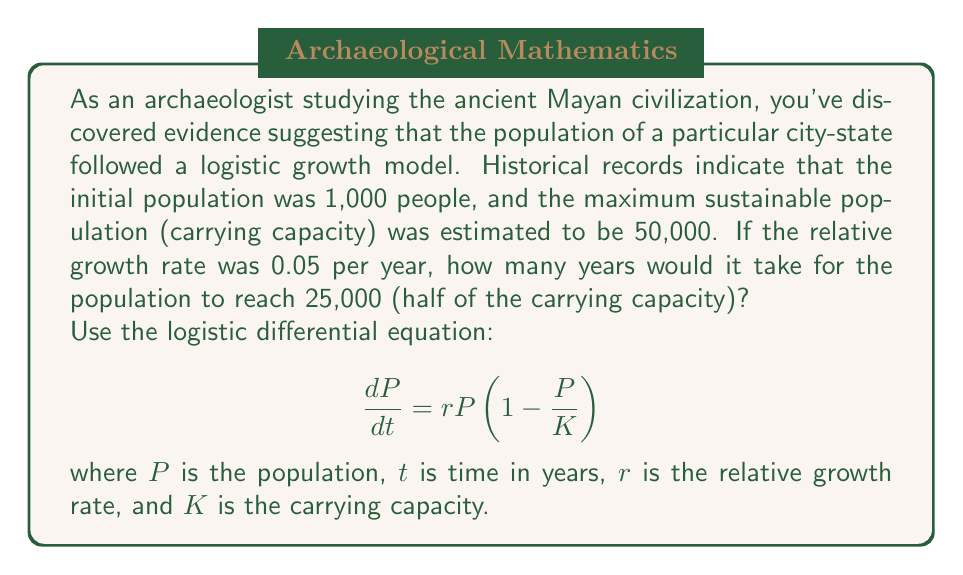Provide a solution to this math problem. To solve this problem, we'll use the analytical solution of the logistic differential equation:

$$P(t) = \frac{K}{1 + (\frac{K}{P_0} - 1)e^{-rt}}$$

Where:
$K = 50,000$ (carrying capacity)
$P_0 = 1,000$ (initial population)
$r = 0.05$ (relative growth rate)
$P(t) = 25,000$ (target population, half of carrying capacity)

Let's substitute these values into the equation:

$$25,000 = \frac{50,000}{1 + (\frac{50,000}{1,000} - 1)e^{-0.05t}}$$

Now, let's solve for $t$:

1) Simplify the fraction:
   $$\frac{1}{2} = \frac{1}{1 + 49e^{-0.05t}}$$

2) Take the reciprocal of both sides:
   $$2 = 1 + 49e^{-0.05t}$$

3) Subtract 1 from both sides:
   $$1 = 49e^{-0.05t}$$

4) Divide both sides by 49:
   $$\frac{1}{49} = e^{-0.05t}$$

5) Take the natural logarithm of both sides:
   $$\ln(\frac{1}{49}) = -0.05t$$

6) Divide both sides by -0.05:
   $$\frac{\ln(\frac{1}{49})}{-0.05} = t$$

7) Simplify:
   $$\frac{\ln(49)}{0.05} = t$$

8) Calculate the final result:
   $$t \approx 77.98 \text{ years}$$

Therefore, it would take approximately 78 years for the population to reach 25,000.
Answer: 78 years 